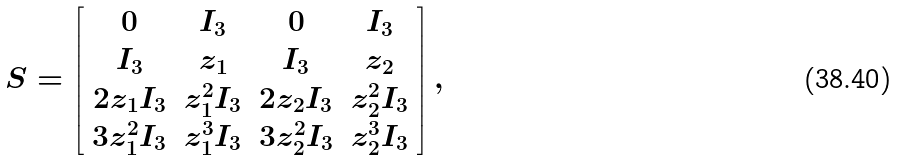Convert formula to latex. <formula><loc_0><loc_0><loc_500><loc_500>S = \left [ \begin{array} { c c c c } 0 & I _ { 3 } & 0 & I _ { 3 } \\ I _ { 3 } & z _ { 1 } & I _ { 3 } & z _ { 2 } \\ 2 z _ { 1 } I _ { 3 } & z _ { 1 } ^ { 2 } I _ { 3 } & 2 z _ { 2 } I _ { 3 } & z _ { 2 } ^ { 2 } I _ { 3 } \\ 3 z _ { 1 } ^ { 2 } I _ { 3 } & z _ { 1 } ^ { 3 } I _ { 3 } & 3 z _ { 2 } ^ { 2 } I _ { 3 } & z _ { 2 } ^ { 3 } I _ { 3 } \\ \end{array} \right ] ,</formula> 